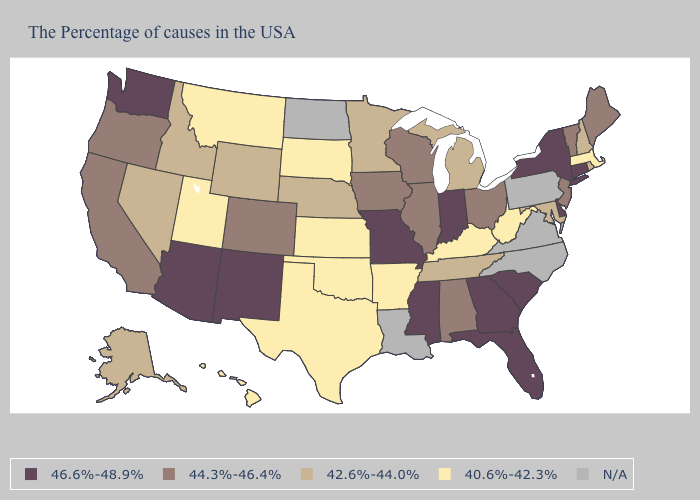Among the states that border Kansas , does Colorado have the lowest value?
Short answer required. No. Which states have the lowest value in the West?
Answer briefly. Utah, Montana, Hawaii. Which states have the highest value in the USA?
Give a very brief answer. Connecticut, New York, Delaware, South Carolina, Florida, Georgia, Indiana, Mississippi, Missouri, New Mexico, Arizona, Washington. What is the value of Alabama?
Quick response, please. 44.3%-46.4%. Name the states that have a value in the range 42.6%-44.0%?
Give a very brief answer. Rhode Island, New Hampshire, Maryland, Michigan, Tennessee, Minnesota, Nebraska, Wyoming, Idaho, Nevada, Alaska. Name the states that have a value in the range 42.6%-44.0%?
Give a very brief answer. Rhode Island, New Hampshire, Maryland, Michigan, Tennessee, Minnesota, Nebraska, Wyoming, Idaho, Nevada, Alaska. What is the value of Idaho?
Concise answer only. 42.6%-44.0%. Name the states that have a value in the range N/A?
Concise answer only. Pennsylvania, Virginia, North Carolina, Louisiana, North Dakota. What is the value of Vermont?
Be succinct. 44.3%-46.4%. What is the highest value in the MidWest ?
Short answer required. 46.6%-48.9%. Name the states that have a value in the range 40.6%-42.3%?
Answer briefly. Massachusetts, West Virginia, Kentucky, Arkansas, Kansas, Oklahoma, Texas, South Dakota, Utah, Montana, Hawaii. Name the states that have a value in the range 40.6%-42.3%?
Write a very short answer. Massachusetts, West Virginia, Kentucky, Arkansas, Kansas, Oklahoma, Texas, South Dakota, Utah, Montana, Hawaii. What is the value of Kentucky?
Keep it brief. 40.6%-42.3%. Among the states that border Montana , does South Dakota have the highest value?
Write a very short answer. No. Name the states that have a value in the range 44.3%-46.4%?
Be succinct. Maine, Vermont, New Jersey, Ohio, Alabama, Wisconsin, Illinois, Iowa, Colorado, California, Oregon. 